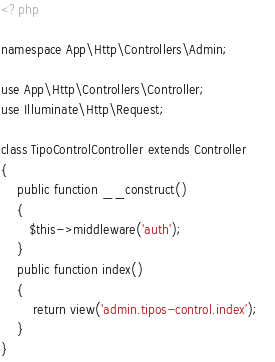<code> <loc_0><loc_0><loc_500><loc_500><_PHP_><?php

namespace App\Http\Controllers\Admin;

use App\Http\Controllers\Controller;
use Illuminate\Http\Request;

class TipoControlController extends Controller
{
    public function __construct()
    {
       $this->middleware('auth');
    }
	public function index()
	{
    	return view('admin.tipos-control.index');	
	}
}
</code> 